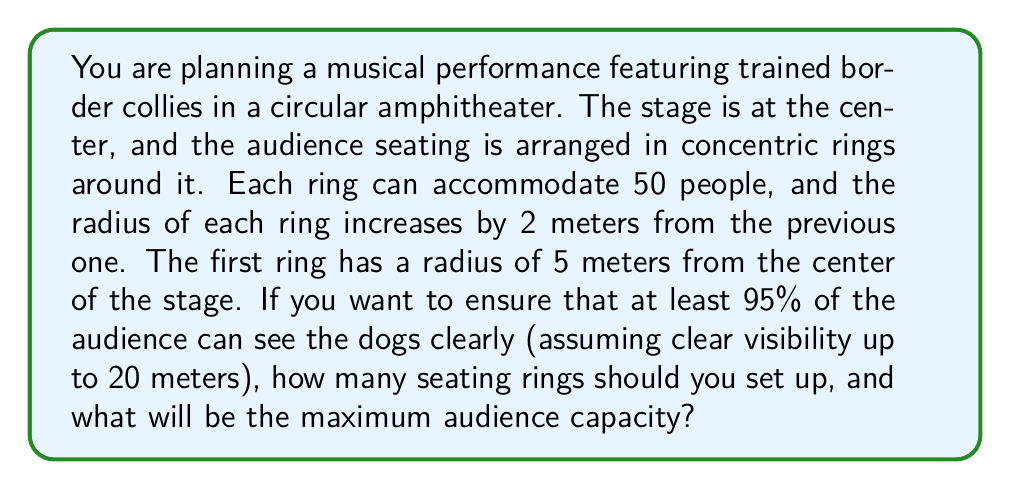Solve this math problem. Let's approach this problem step-by-step:

1) First, we need to determine how many rings can be placed within the 20-meter visibility limit.

2) The radius of each ring can be expressed as:
   $r_n = 5 + 2(n-1)$, where $n$ is the ring number

3) We need to find the largest $n$ such that $r_n \leq 20$:
   $5 + 2(n-1) \leq 20$
   $2n - 2 \leq 15$
   $2n \leq 17$
   $n \leq 8.5$

4) Therefore, the maximum number of rings within 20 meters is 8.

5) Now, we need to calculate the total number of people in these 8 rings:
   $8 \times 50 = 400$ people

6) To ensure that at least 95% of the audience can see clearly, we can add one more ring:
   $9 \times 50 = 450$ people, of which 400 (88.89%) can see clearly

7) To calculate the total number of rings needed, we use the formula:
   $0.95 \times \text{total audience} \leq 400$
   $\text{total audience} \leq \frac{400}{0.95} \approx 421.05$

8) The number of rings needed is:
   $\lceil \frac{421.05}{50} \rceil = 9$ rings

9) The maximum audience capacity is thus:
   $9 \times 50 = 450$ people
Answer: The optimal seating arrangement requires 9 concentric rings, providing a maximum audience capacity of 450 people, with 95.24% (428 out of 450) of the audience having clear visibility of the dog performers. 